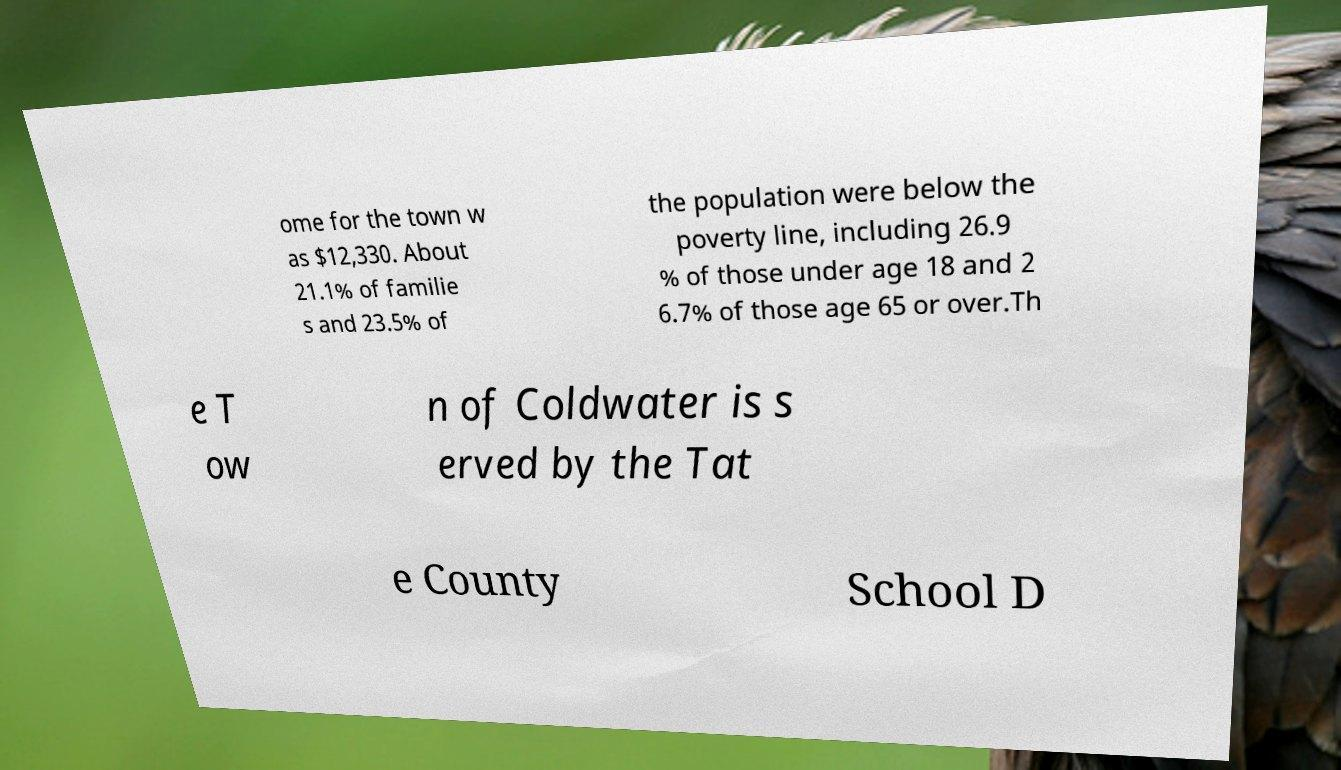For documentation purposes, I need the text within this image transcribed. Could you provide that? ome for the town w as $12,330. About 21.1% of familie s and 23.5% of the population were below the poverty line, including 26.9 % of those under age 18 and 2 6.7% of those age 65 or over.Th e T ow n of Coldwater is s erved by the Tat e County School D 